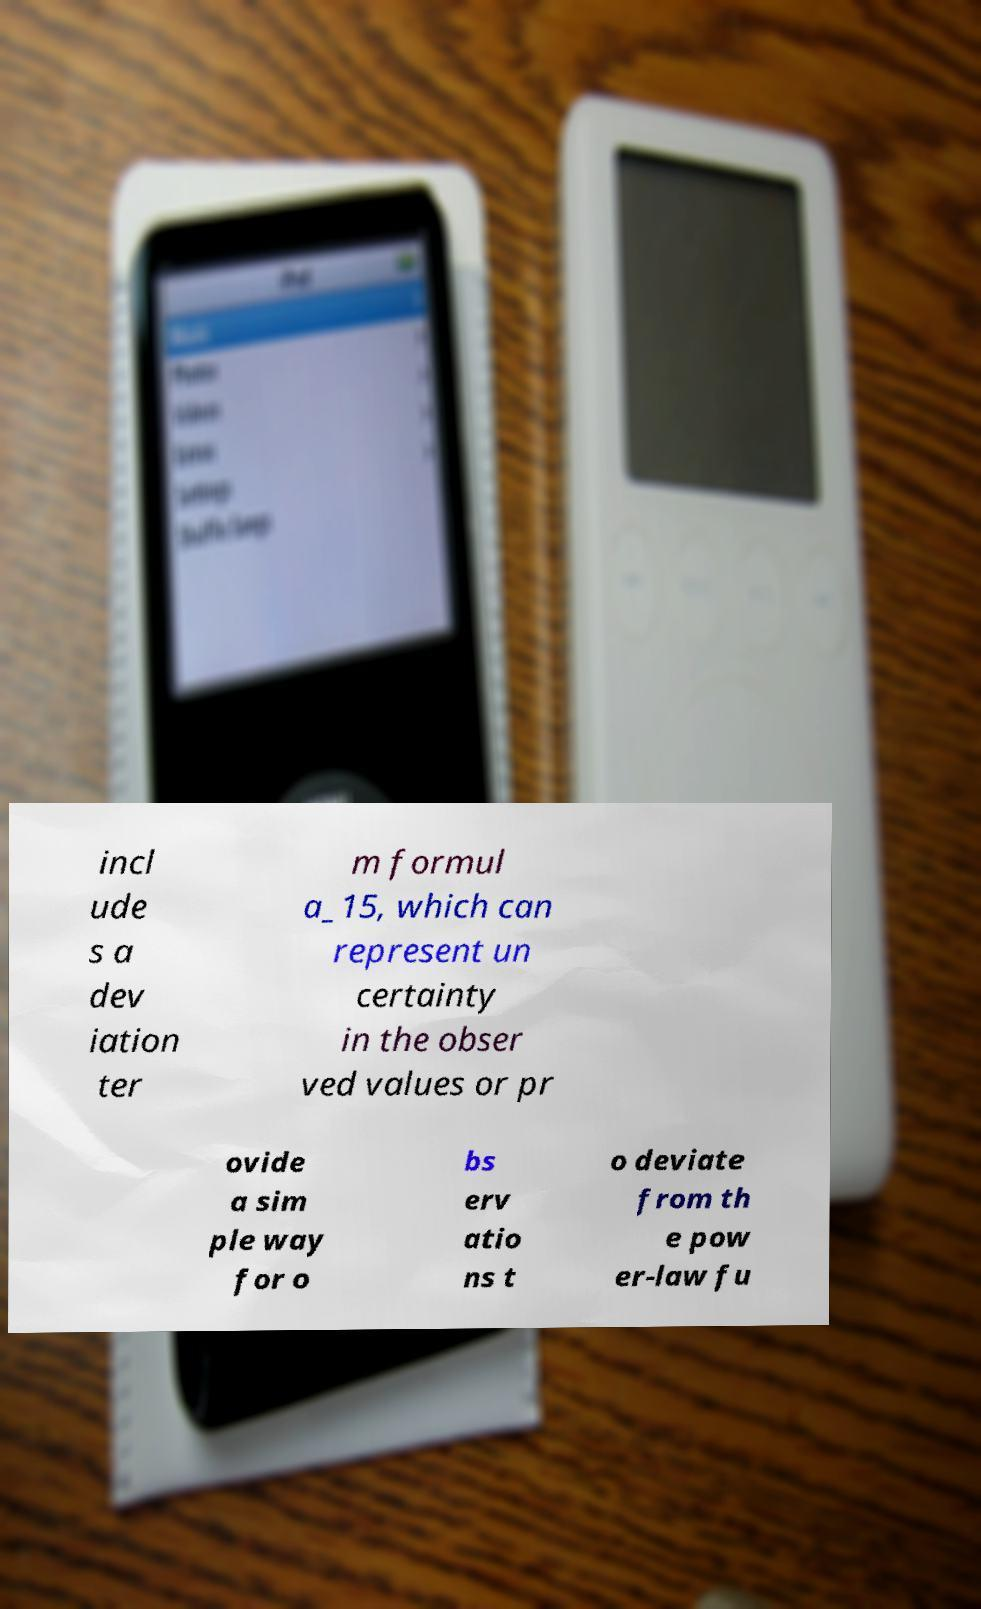There's text embedded in this image that I need extracted. Can you transcribe it verbatim? incl ude s a dev iation ter m formul a_15, which can represent un certainty in the obser ved values or pr ovide a sim ple way for o bs erv atio ns t o deviate from th e pow er-law fu 